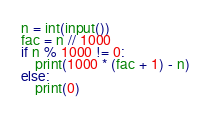Convert code to text. <code><loc_0><loc_0><loc_500><loc_500><_Python_>n = int(input())
fac = n // 1000
if n % 1000 != 0:
    print(1000 * (fac + 1) - n)
else:
    print(0)</code> 